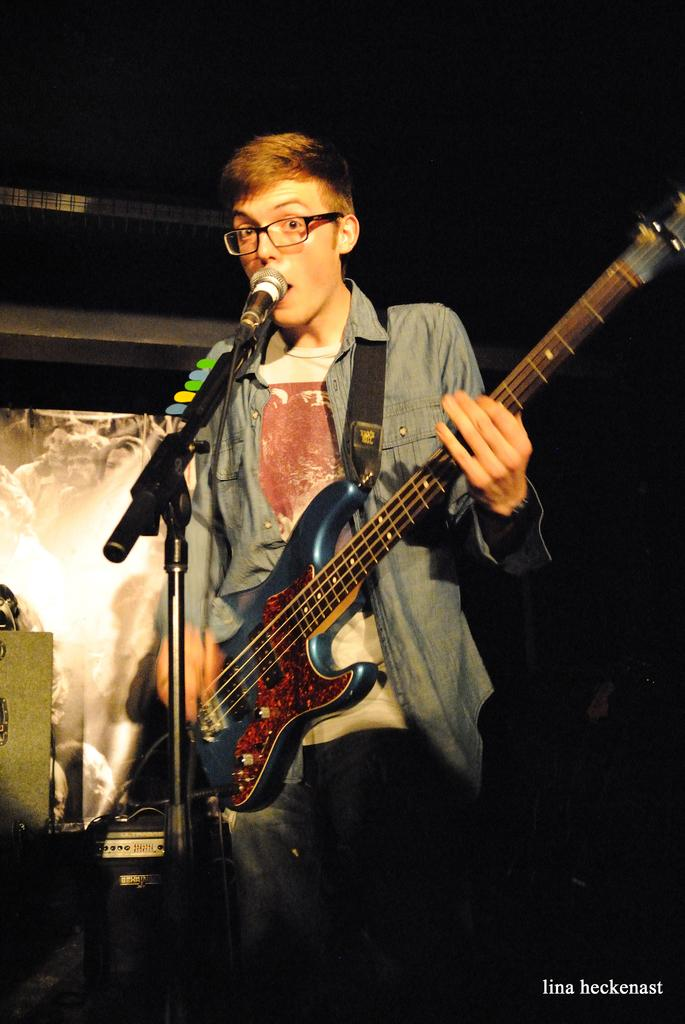Who is the main subject in the picture? There is a person in the picture. Where is the person located in the image? The person is standing in the middle of the image. What is the person holding in his hands? The person is holding a guitar in his hands. What equipment is in front of the person? There is a mic and stand in front of the person. What can be observed about the background of the image? The background of the image is dark. What type of flock can be seen flying in the background of the image? There is no flock visible in the image; the background is dark. What effect does the person's guitar playing have on the audience in the image? There is no audience present in the image, so it is not possible to determine the effect of the person's guitar playing on them. 